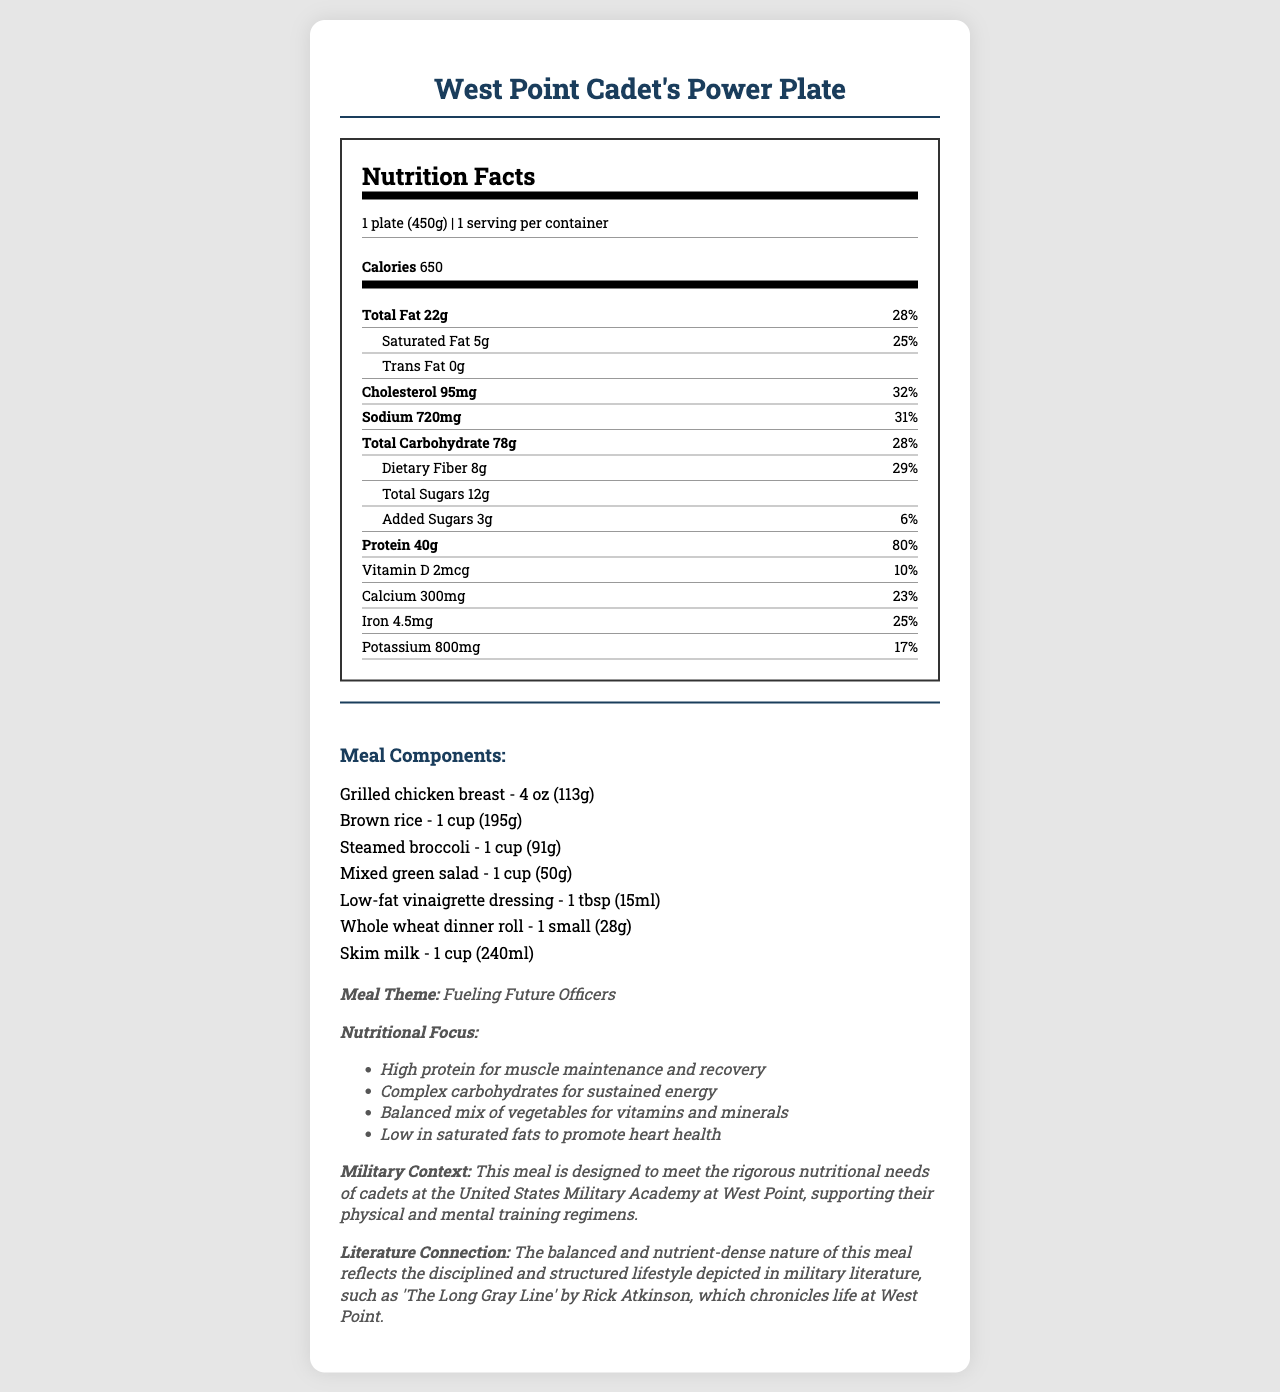what is the serving size for the meal? The serving size is stated at the beginning of the nutrition label under "serving size."
Answer: 1 plate (450g) How many calories are in one serving of the meal? The calorie content is prominently displayed under "Calories" in the nutrition facts section.
Answer: 650 calories What is the amount of protein in the meal? The protein content is listed under "Protein" in the nutrition facts section.
Answer: 40g Does this meal contain any trans fat? The amount of trans fat is listed as 0g under "Trans Fat."
Answer: No What is the daily value percentage of dietary fiber in the meal? The daily value percentage for dietary fiber is given as 29% in the nutrition label.
Answer: 29% How much sodium does this meal contain? A. 500mg B. 600mg C. 720mg D. 800mg The sodium content listed in the nutrition facts is 720mg.
Answer: C What is the main theme of this meal? I. Balanced Nutrition II. Fueling Future Officers III. High Calorie IV. Vegetarian The main theme is "Fueling Future Officers," as noted in the additional information section of the document.
Answer: II Is this meal high in protein? The meal contains 40g of protein, which is 80% of the daily value, indicating it is high in protein.
Answer: Yes Summarize the detailed nutrient breakdown of the cafeteria meal at the military academy. This summary covers the key sections of the document, including the main details and additional context provided.
Answer: The document provides a comprehensive nutrition label for the "West Point Cadet's Power Plate," listing serving size, calorie content, and amounts of various nutrients such as fats, cholesterol, sodium, carbohydrates, fiber, sugars, and protein. It also describes the meal components, which include grilled chicken breast, brown rice, steamed broccoli, mixed green salad, low-fat vinaigrette dressing, a whole wheat dinner roll, and skim milk. Additionally, it notes the meal's theme, nutritional focus, and its relevance to military training and literature. What vitamins and minerals are included in the meal's nutritional breakdown? The nutrition label lists these vitamins and minerals along with their amounts and daily value percentages.
Answer: Vitamin D, Calcium, Iron, and Potassium How does the document link the meal to military literature? This is mentioned in the additional information section under "Literature Connection."
Answer: It mentions that the balanced and nutrient-dense nature of the meal reflects the disciplined and structured lifestyle depicted in military literature, such as "The Long Gray Line" by Rick Atkinson. What percentage of the daily value for calcium does the meal provide? The daily value percentage for calcium is listed as 23% in the nutrition label.
Answer: 23% What is included in the additional information section about the meal's nutritional focus? This information is detailed in the additional information section under "Nutritional Focus."
Answer: High protein for muscle maintenance and recovery, complex carbohydrates for sustained energy, balanced mix of vegetables for vitamins and minerals, low in saturated fats to promote heart health How many grams of total sugars are in the meal? The nutrition label lists the total sugars amount as 12g.
Answer: 12g What amount of cholesterol does this meal contain, and what is its daily value percentage? The cholesterol content is listed as 95mg, with a daily value percentage of 32%.
Answer: 95mg, 32% What is the significance of this meal being low in saturated fats? The additional information section mentions that low saturated fats are included to promote heart health.
Answer: It promotes heart health. Who is the meal specifically designed to meet the nutritional needs of? This information is given in the military context within the additional information section.
Answer: Cadets at the United States Military Academy at West Point Is this meal primarily vegetarian? The meal contains grilled chicken breast, indicating it is not vegetarian.
Answer: No What is the amount of added sugars in the meal? The nutrition label lists the added sugars amount as 3g.
Answer: 3g What specific meal components are part of the "West Point Cadet's Power Plate?" The meal components are listed in a dedicated section under "Meal Components."
Answer: Grilled chicken breast, brown rice, steamed broccoli, mixed green salad, low-fat vinaigrette dressing, whole wheat dinner roll, skim milk What is the total carbohydrate content in grams of the meal? The nutrition label lists the total carbohydrates amount as 78g.
Answer: 78g In what ways does the meal support the physical and mental training regimens of cadets? The additional information section explains how the meal supports the rigorous nutritional needs of cadets.
Answer: The meal is high in protein for muscle recovery, contains complex carbohydrates for sustained energy, provides a balanced mix of vegetables for vitamins and minerals, and is low in saturated fats to promote heart health. 